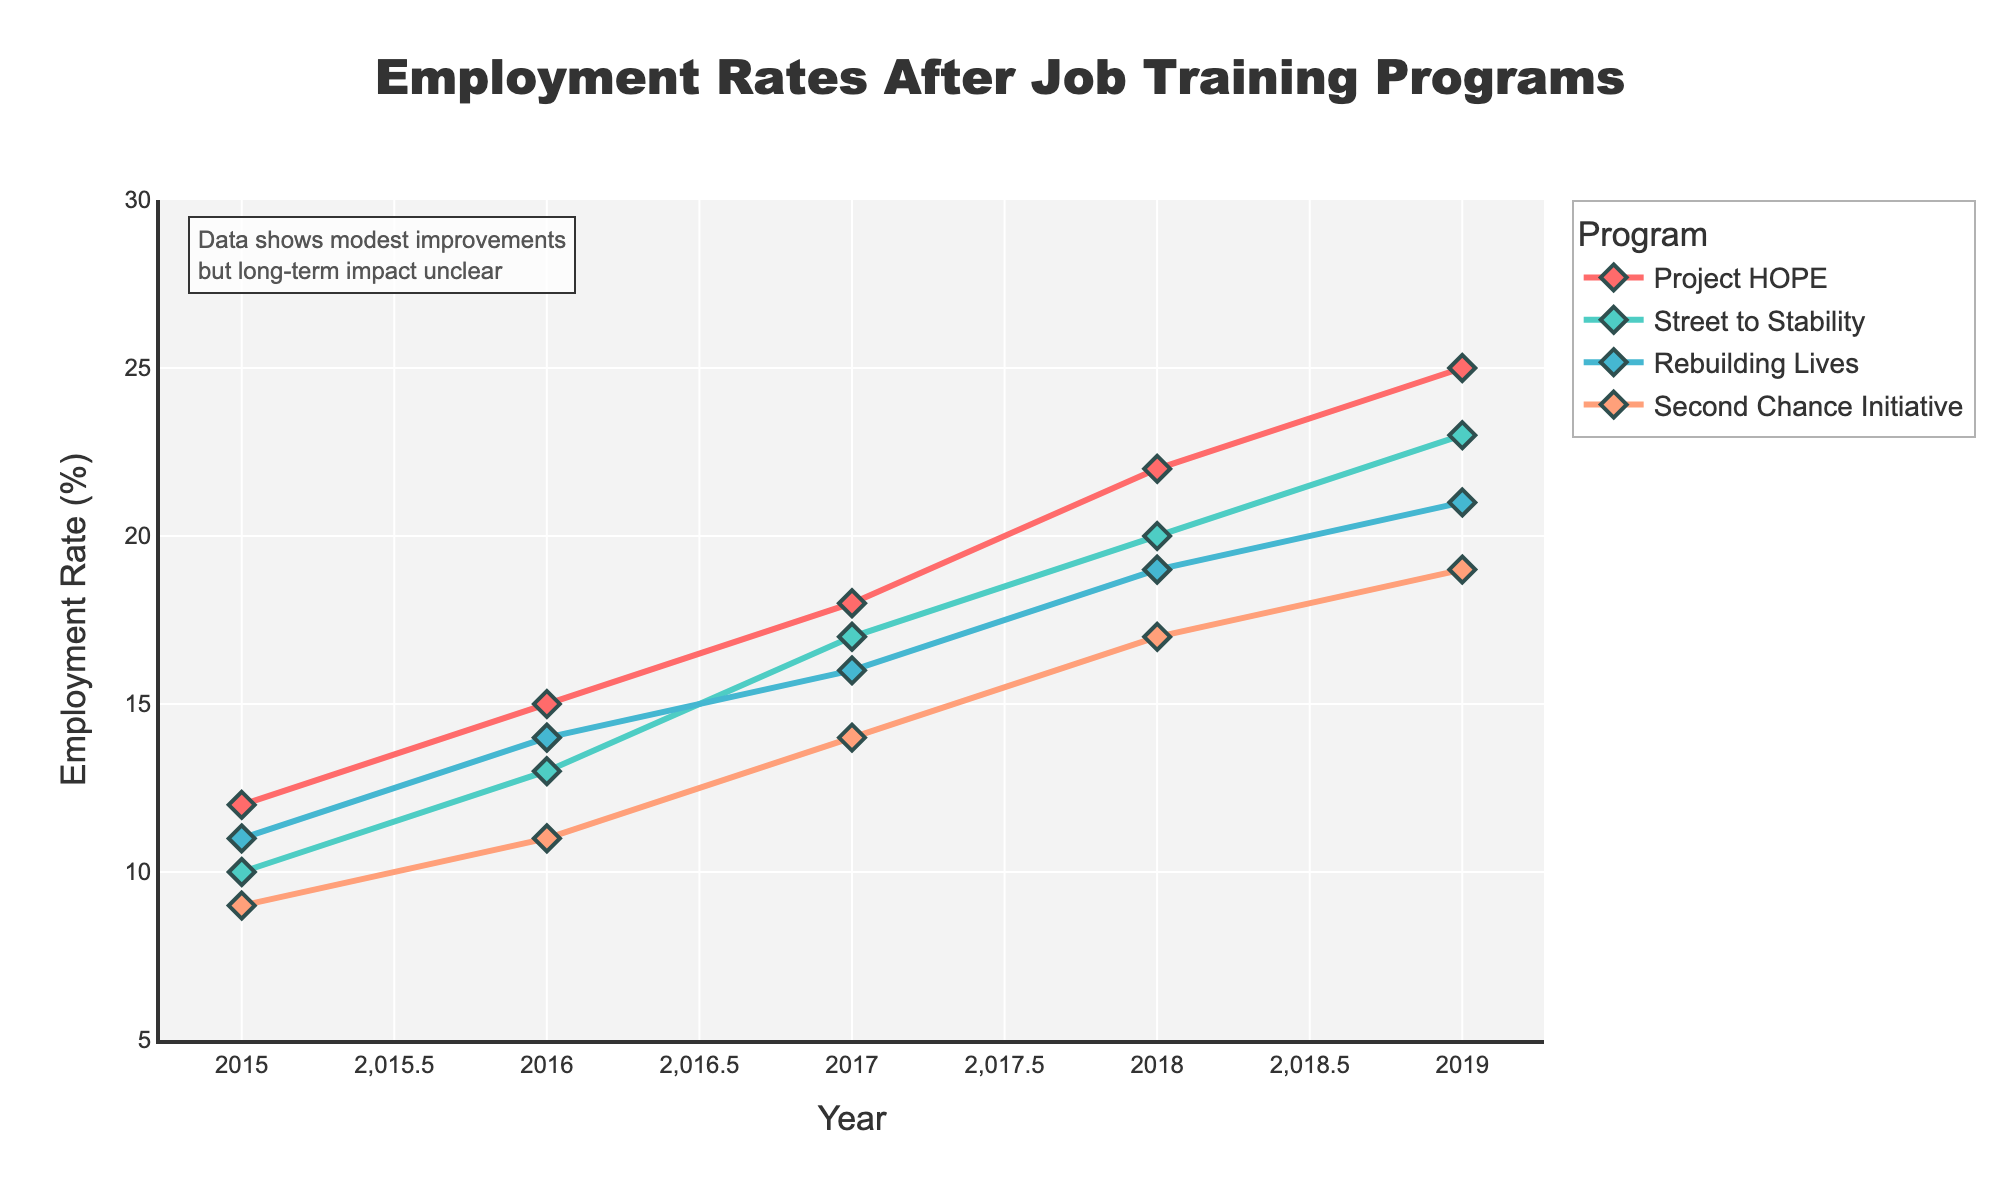What's the employment rate for Rebuilding Lives in 2018? Locate the data point for Rebuilding Lives in the year 2018. The employment rate is 19%.
Answer: 19% Which program had the highest employment rate in 2019? Compare the data points for all programs in 2019. Project HOPE had the highest employment rate at 25%.
Answer: Project HOPE Did any program have a decreasing trend in employment rates from 2015 to 2019? Check the trend lines for all programs. None of the programs showed a decreasing trend; all displayed an increasing trend.
Answer: No By how much did the employment rate of Street to Stability increase from 2015 to 2019? Subtract the employment rate of Street to Stability in 2015 (10%) from that in 2019 (23%). 23% - 10% = 13%.
Answer: 13% Which program had the lowest employment rate in 2015 and what was the rate? Compare the employment rates for all programs in 2015. The Second Chance Initiative had the lowest rate at 9%.
Answer: Second Chance Initiative, 9% What is the average employment rate for Rebuilding Lives over the years 2015 to 2019? Add the employment rates for Rebuilding Lives from 2015 to 2019 (11% + 14% + 16% + 19% + 21%) and divide by 5. (11+14+16+19+21)/5 = 16.2%.
Answer: 16.2% How did the employment rate change for Project HOPE between 2017 and 2019? Subtract the employment rate in 2017 (18%) from that in 2019 (25%). The employment rate increased by 7%.
Answer: 7% Which two programs have the closest employment rates in 2018? Compare the employment rates across all programs in 2018: Project HOPE (22%), Street to Stability (20%), Rebuilding Lives (19%), Second Chance Initiative (17%). The closest rates are Street to Stability and Rebuilding Lives with a difference of 1%.
Answer: Street to Stability and Rebuilding Lives Rank the programs by their employment rate increase from 2015 to 2019. Calculate the increase for each program from 2015 to 2019:
- Project HOPE: 25% - 12% = 13%
- Street to Stability: 23% - 10% = 13%
- Rebuilding Lives: 21% - 11% = 10%
- Second Chance Initiative: 19% - 9% = 10%
Rank: Project HOPE = Street to Stability > Rebuilding Lives = Second Chance Initiative.
Answer: Project HOPE = Street to Stability > Rebuilding Lives = Second Chance Initiative 